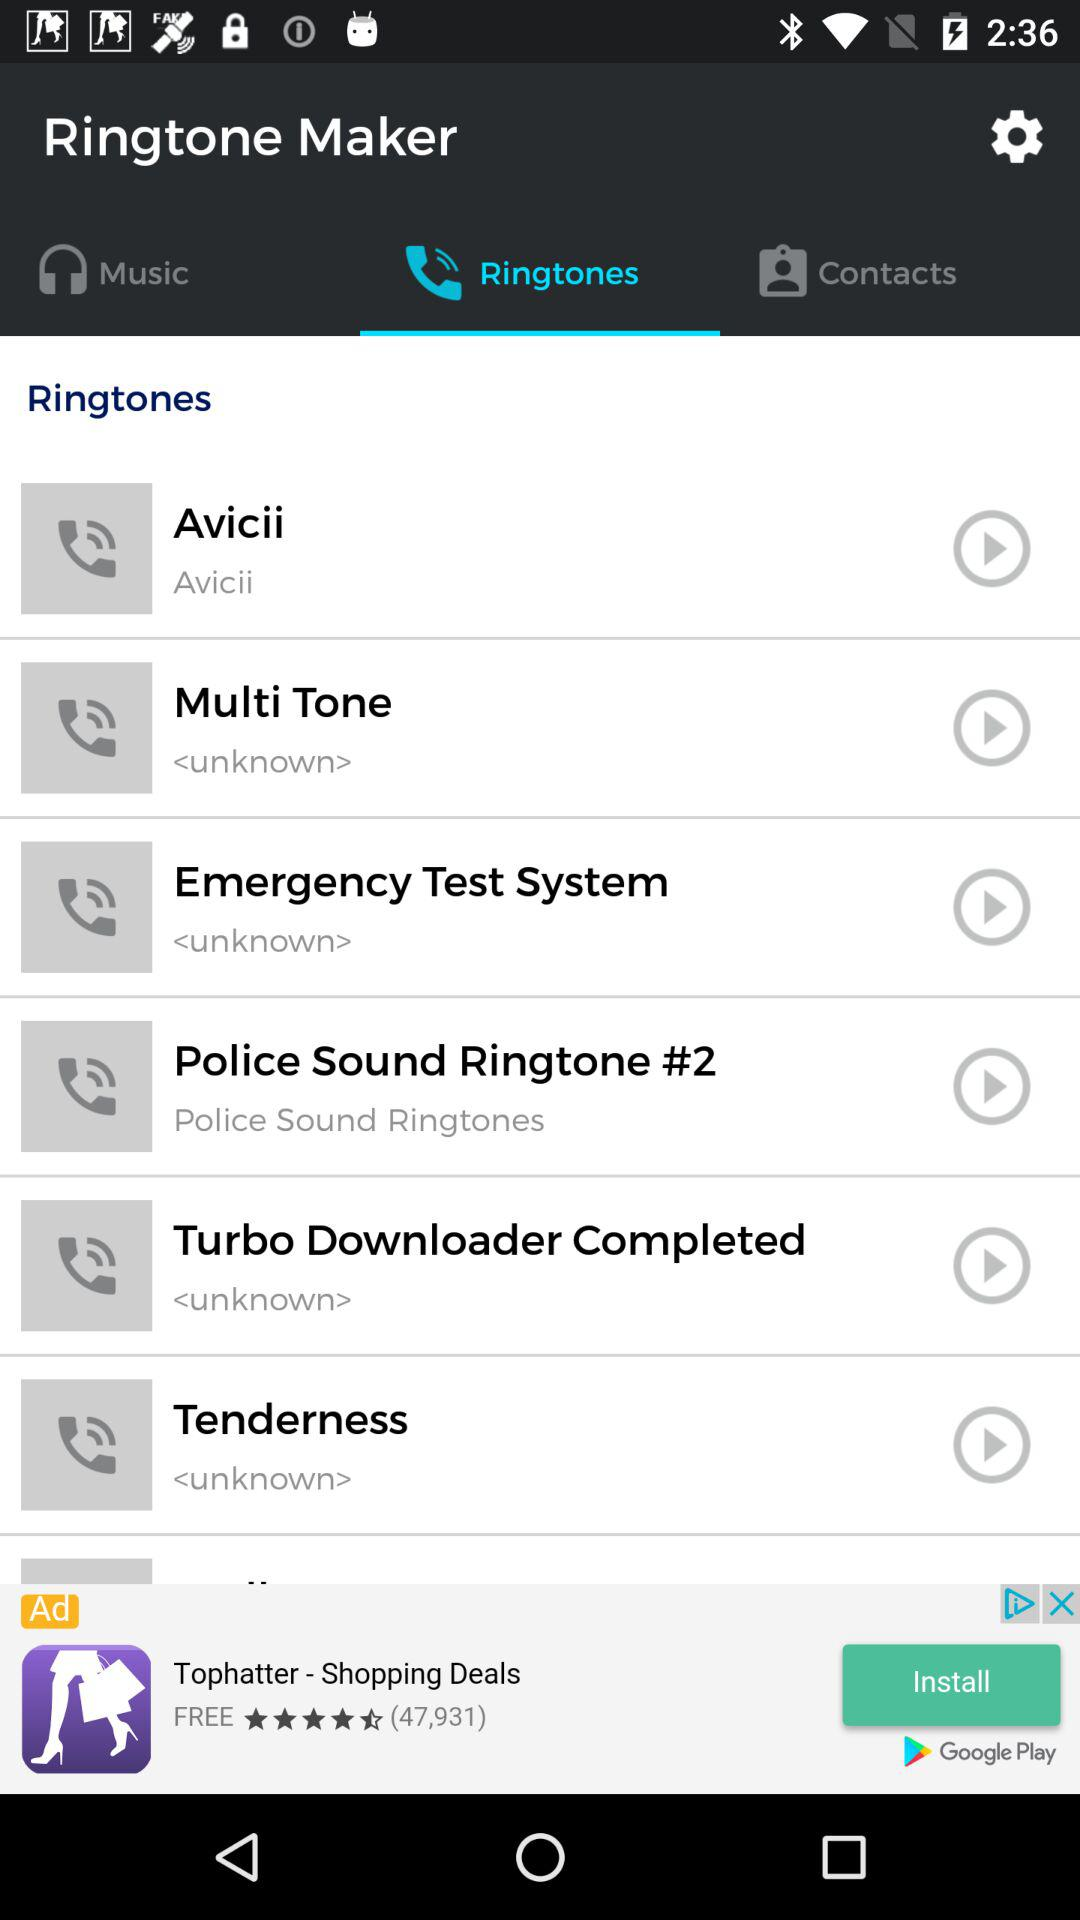Which tab is selected? The selected tab is "Ringtones". 